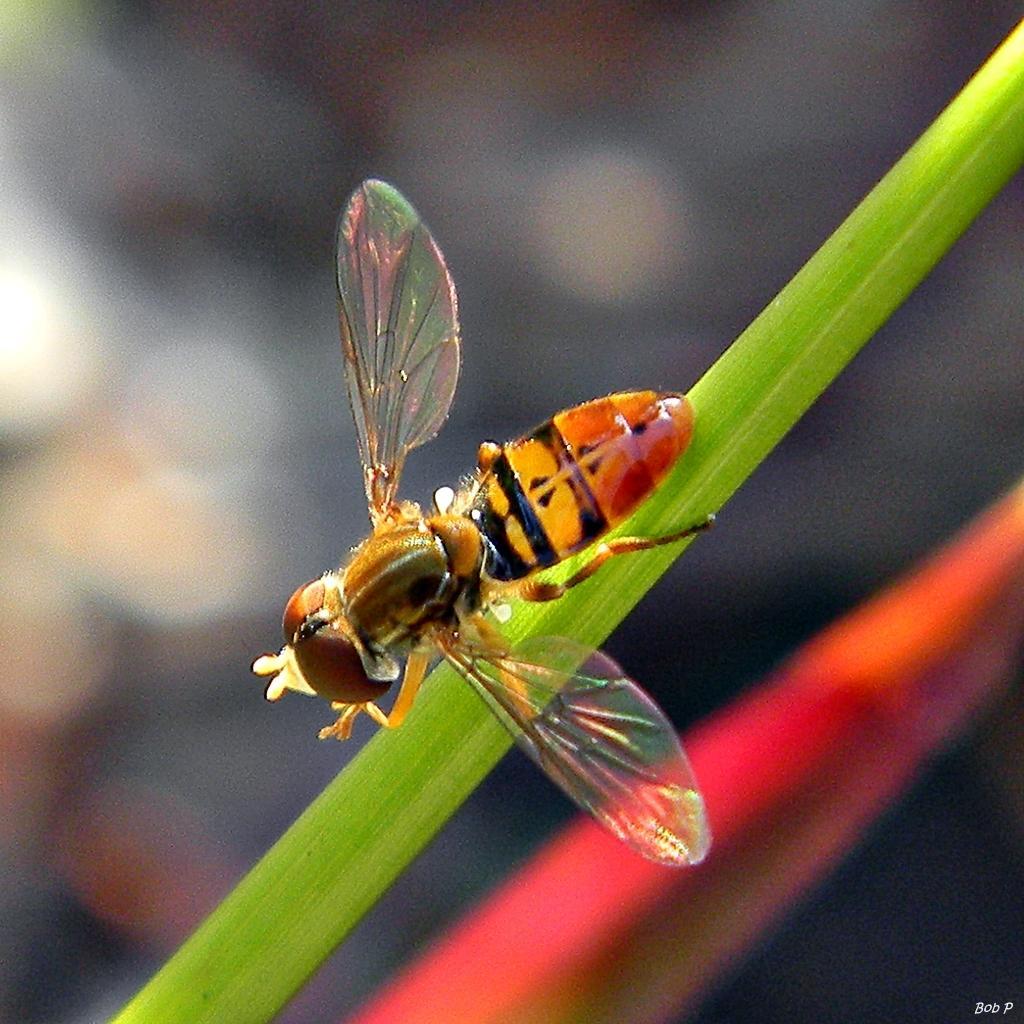Please provide a concise description of this image. In this image we can see a honey bee on the stem. 